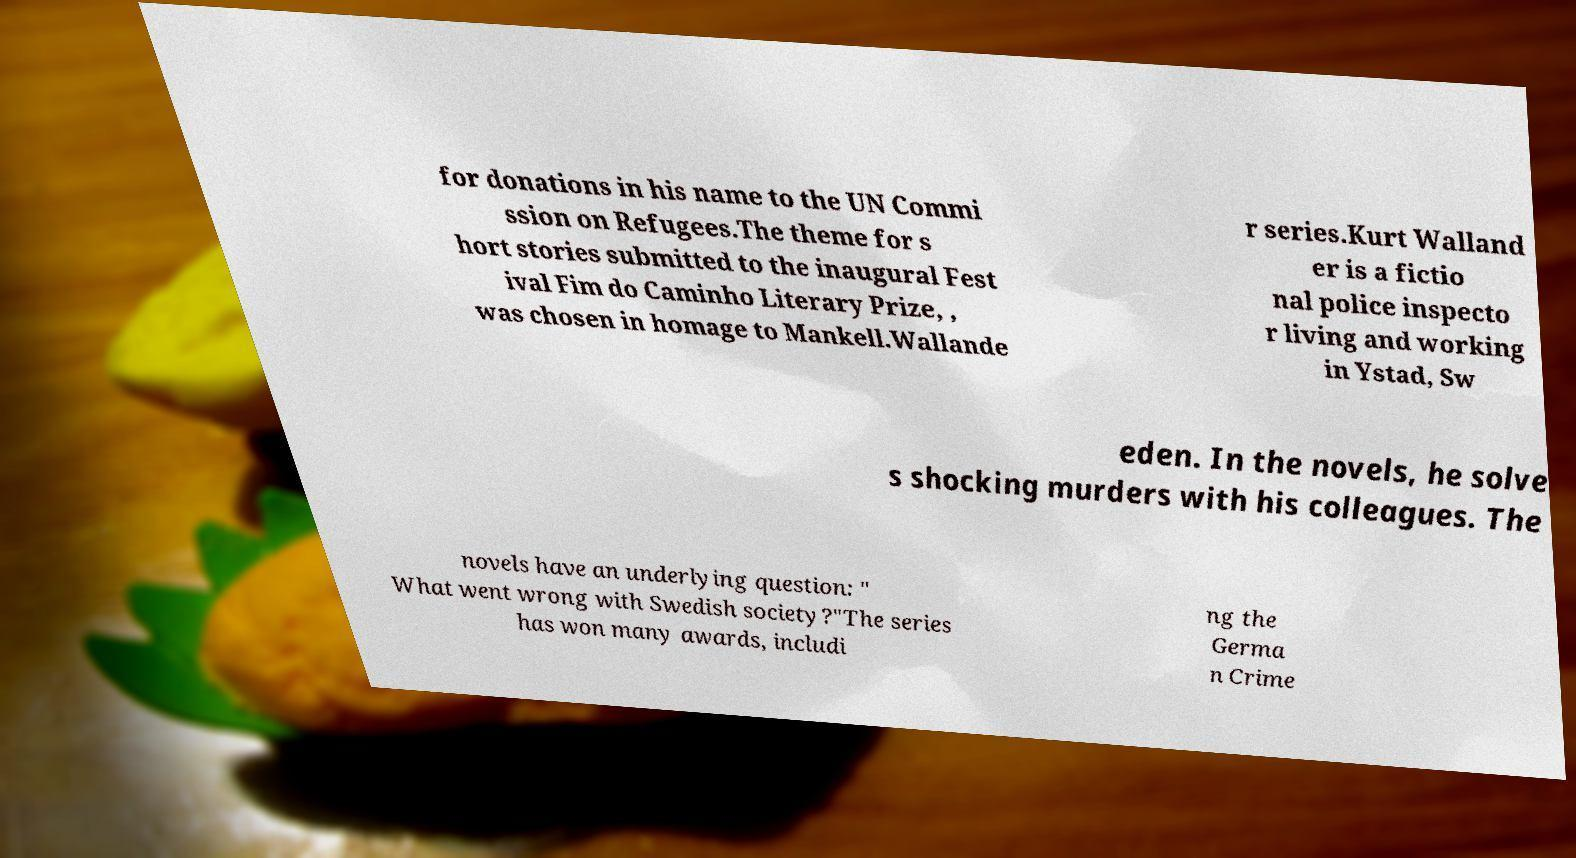I need the written content from this picture converted into text. Can you do that? for donations in his name to the UN Commi ssion on Refugees.The theme for s hort stories submitted to the inaugural Fest ival Fim do Caminho Literary Prize, , was chosen in homage to Mankell.Wallande r series.Kurt Walland er is a fictio nal police inspecto r living and working in Ystad, Sw eden. In the novels, he solve s shocking murders with his colleagues. The novels have an underlying question: " What went wrong with Swedish society?"The series has won many awards, includi ng the Germa n Crime 